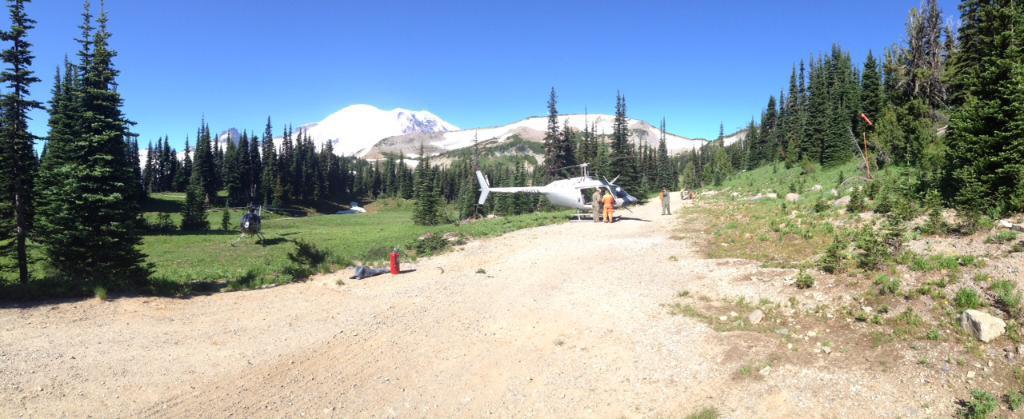Can you describe this image briefly? At the center of the image there is an airplane. In front of the airplane there are two persons standing. On the right and left side of the image there are trees. In the background there is a mountain and sky. 